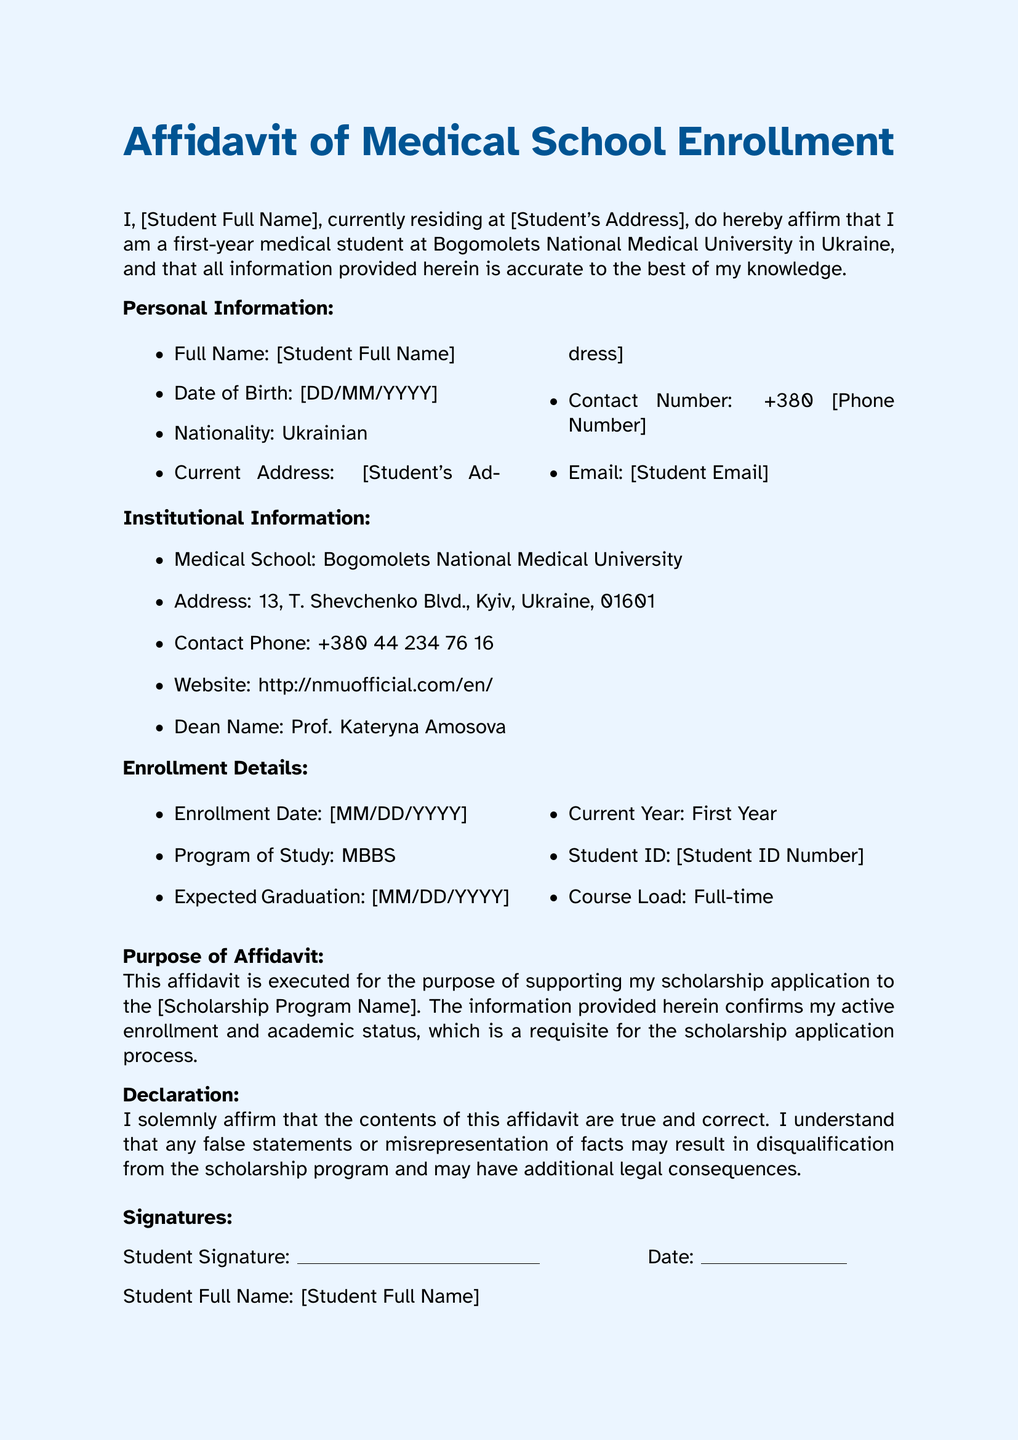What is the name of the medical school? The name of the medical school is specified in the "Institutional Information" section of the document.
Answer: Bogomolets National Medical University What is the student ID? The student ID is mentioned in the "Enrollment Details."
Answer: [Student ID Number] Who is the Dean of the medical school? The name of the Dean is provided in the "Institutional Information" section.
Answer: Prof. Kateryna Amosova What is the expected graduation date? The expected graduation date is included in the "Enrollment Details" section of the affidavit.
Answer: [MM/DD/YYYY] What program of study is the student enrolled in? The program of study is noted in the "Enrollment Details."
Answer: MBBS What is the purpose of the affidavit? The purpose is outlined under the "Purpose of Affidavit" section.
Answer: Scholarship application What language is the affidavit written in? The language used in the document is indicated by the terms and phrases presented throughout the text.
Answer: English What must the student do to affirm the affidavit is true? The document requires a statement of understanding regarding the truthfulness of its contents.
Answer: Affirm contents are true What does the notarization section include? The notarization section consists of signatures and a stamp required to validate the affidavit.
Answer: Signatures and official stamp/seal 